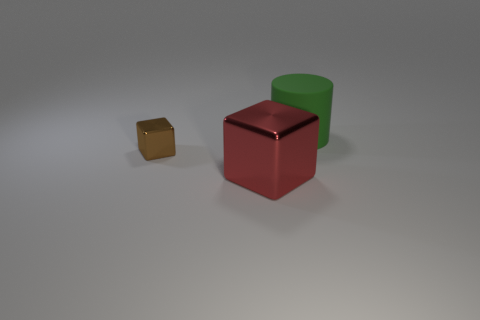Add 1 red objects. How many objects exist? 4 Subtract all cylinders. How many objects are left? 2 Subtract all small blue metallic cubes. Subtract all cylinders. How many objects are left? 2 Add 2 big rubber cylinders. How many big rubber cylinders are left? 3 Add 1 brown metallic objects. How many brown metallic objects exist? 2 Subtract 0 purple blocks. How many objects are left? 3 